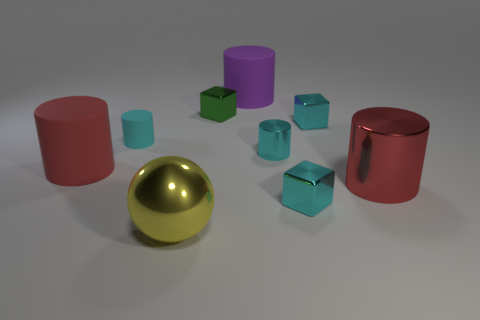Subtract all green cubes. How many cubes are left? 2 Subtract all big red cylinders. How many cylinders are left? 3 Subtract all cylinders. How many objects are left? 4 Subtract 3 cubes. How many cubes are left? 0 Add 1 small green shiny objects. How many objects exist? 10 Subtract all cyan balls. How many red cylinders are left? 2 Subtract all large red rubber objects. Subtract all small rubber cylinders. How many objects are left? 7 Add 7 green blocks. How many green blocks are left? 8 Add 6 rubber cylinders. How many rubber cylinders exist? 9 Subtract 0 cyan balls. How many objects are left? 9 